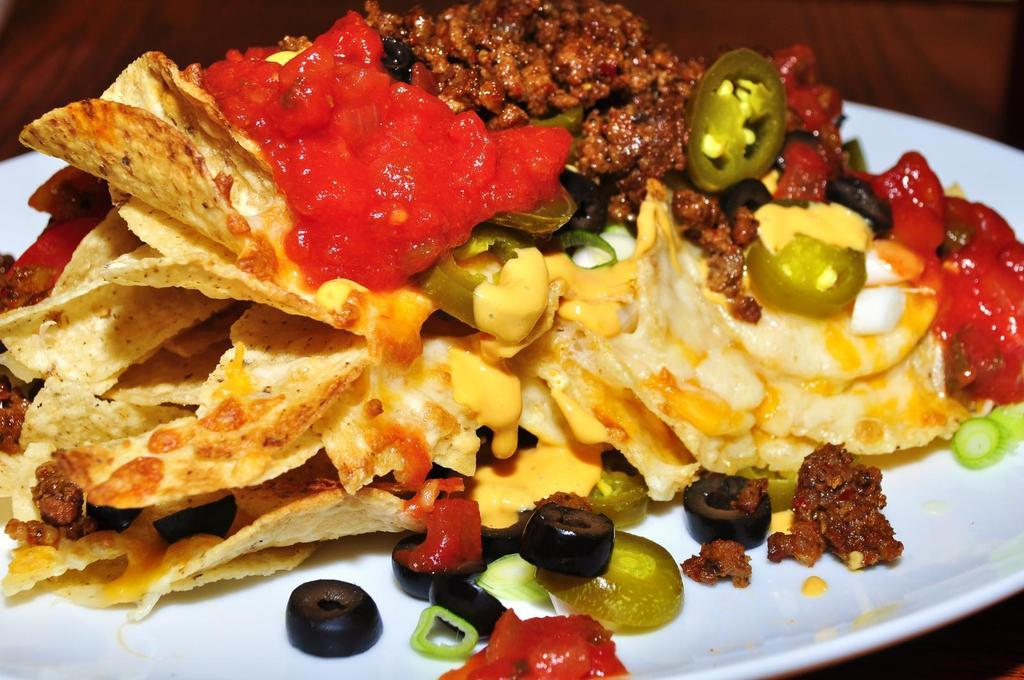What is present on the plate in the image? There are food items on the plate in the image. Where is the plate located? The plate is on a table. What type of toys can be seen on the plate in the image? There are no toys present on the plate in the image; it contains food items. 